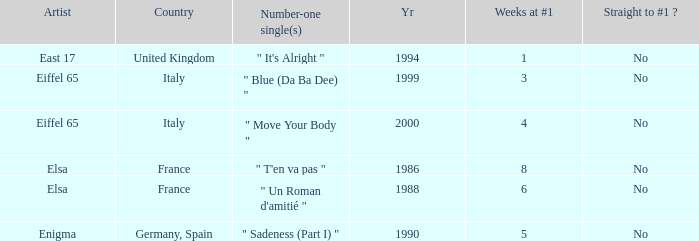How many years have a weeks at #1 value of exactly 8? 1.0. 